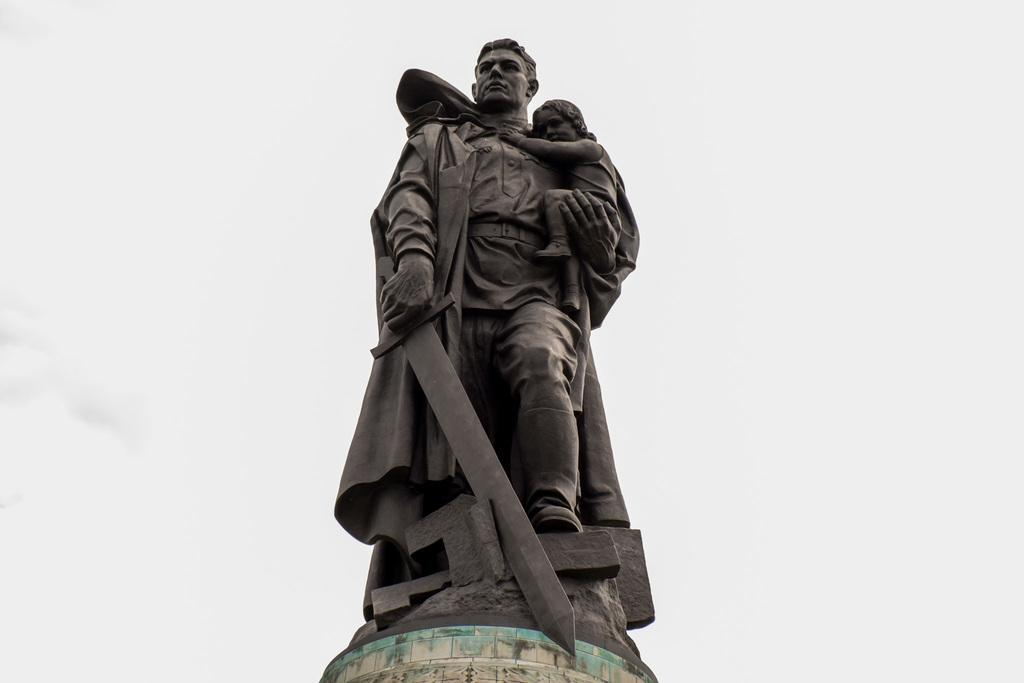What is the main subject of the image? There is a statue in the image. What can be seen in the background of the image? The sky is visible in the background of the image. What type of authority is depicted in the statue's finger in the image? There is no authority or finger depicted in the statue in the image. How many divisions can be seen in the statue in the image? There are no divisions present in the statue in the image. 